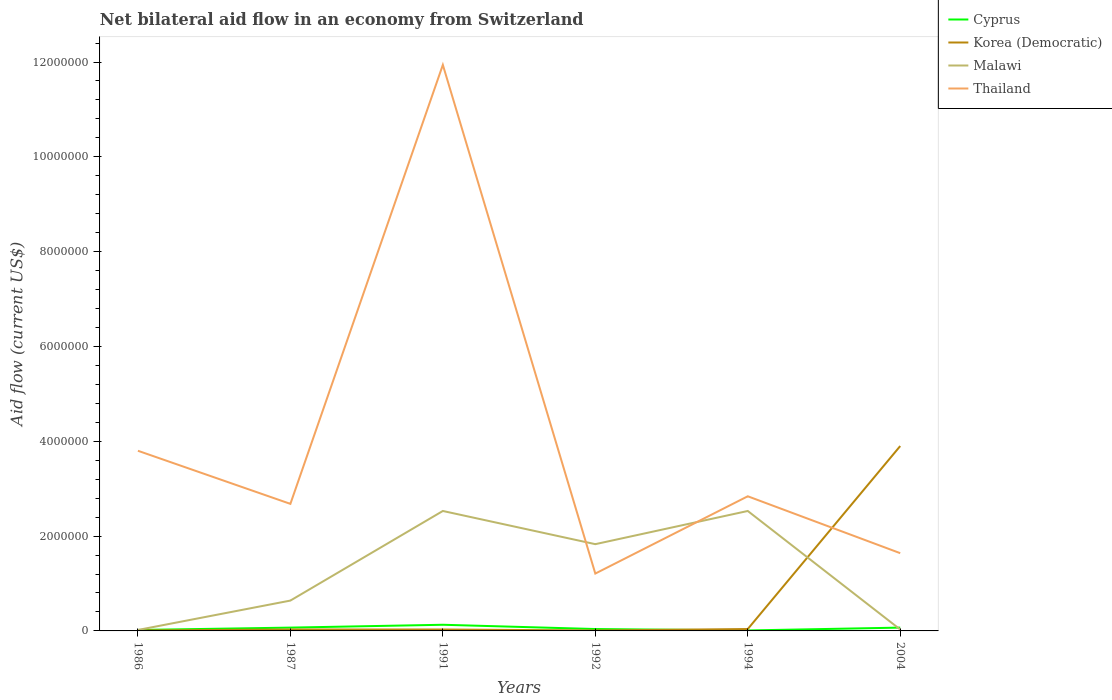How many different coloured lines are there?
Your answer should be compact. 4. Does the line corresponding to Korea (Democratic) intersect with the line corresponding to Malawi?
Your response must be concise. Yes. Is the number of lines equal to the number of legend labels?
Offer a terse response. Yes. What is the difference between the highest and the second highest net bilateral aid flow in Malawi?
Ensure brevity in your answer.  2.51e+06. What is the difference between two consecutive major ticks on the Y-axis?
Provide a short and direct response. 2.00e+06. Are the values on the major ticks of Y-axis written in scientific E-notation?
Make the answer very short. No. Does the graph contain grids?
Offer a terse response. No. How many legend labels are there?
Offer a terse response. 4. What is the title of the graph?
Keep it short and to the point. Net bilateral aid flow in an economy from Switzerland. Does "Pakistan" appear as one of the legend labels in the graph?
Your answer should be very brief. No. What is the label or title of the X-axis?
Give a very brief answer. Years. What is the label or title of the Y-axis?
Your answer should be compact. Aid flow (current US$). What is the Aid flow (current US$) in Thailand in 1986?
Your answer should be compact. 3.80e+06. What is the Aid flow (current US$) of Korea (Democratic) in 1987?
Give a very brief answer. 3.00e+04. What is the Aid flow (current US$) in Malawi in 1987?
Provide a short and direct response. 6.40e+05. What is the Aid flow (current US$) of Thailand in 1987?
Give a very brief answer. 2.68e+06. What is the Aid flow (current US$) in Malawi in 1991?
Ensure brevity in your answer.  2.53e+06. What is the Aid flow (current US$) of Thailand in 1991?
Offer a very short reply. 1.19e+07. What is the Aid flow (current US$) in Cyprus in 1992?
Give a very brief answer. 4.00e+04. What is the Aid flow (current US$) in Korea (Democratic) in 1992?
Offer a terse response. 10000. What is the Aid flow (current US$) of Malawi in 1992?
Keep it short and to the point. 1.83e+06. What is the Aid flow (current US$) of Thailand in 1992?
Provide a short and direct response. 1.21e+06. What is the Aid flow (current US$) in Korea (Democratic) in 1994?
Your answer should be compact. 4.00e+04. What is the Aid flow (current US$) in Malawi in 1994?
Your response must be concise. 2.53e+06. What is the Aid flow (current US$) in Thailand in 1994?
Your answer should be very brief. 2.84e+06. What is the Aid flow (current US$) of Cyprus in 2004?
Your answer should be compact. 7.00e+04. What is the Aid flow (current US$) of Korea (Democratic) in 2004?
Give a very brief answer. 3.90e+06. What is the Aid flow (current US$) of Thailand in 2004?
Offer a terse response. 1.64e+06. Across all years, what is the maximum Aid flow (current US$) of Korea (Democratic)?
Offer a very short reply. 3.90e+06. Across all years, what is the maximum Aid flow (current US$) in Malawi?
Give a very brief answer. 2.53e+06. Across all years, what is the maximum Aid flow (current US$) in Thailand?
Your response must be concise. 1.19e+07. Across all years, what is the minimum Aid flow (current US$) of Cyprus?
Your response must be concise. 10000. Across all years, what is the minimum Aid flow (current US$) of Korea (Democratic)?
Your response must be concise. 10000. Across all years, what is the minimum Aid flow (current US$) in Thailand?
Keep it short and to the point. 1.21e+06. What is the total Aid flow (current US$) in Cyprus in the graph?
Offer a terse response. 3.40e+05. What is the total Aid flow (current US$) of Korea (Democratic) in the graph?
Give a very brief answer. 4.02e+06. What is the total Aid flow (current US$) in Malawi in the graph?
Give a very brief answer. 7.58e+06. What is the total Aid flow (current US$) of Thailand in the graph?
Offer a terse response. 2.41e+07. What is the difference between the Aid flow (current US$) of Malawi in 1986 and that in 1987?
Ensure brevity in your answer.  -6.20e+05. What is the difference between the Aid flow (current US$) in Thailand in 1986 and that in 1987?
Give a very brief answer. 1.12e+06. What is the difference between the Aid flow (current US$) of Cyprus in 1986 and that in 1991?
Offer a terse response. -1.10e+05. What is the difference between the Aid flow (current US$) in Malawi in 1986 and that in 1991?
Offer a very short reply. -2.51e+06. What is the difference between the Aid flow (current US$) of Thailand in 1986 and that in 1991?
Keep it short and to the point. -8.14e+06. What is the difference between the Aid flow (current US$) in Korea (Democratic) in 1986 and that in 1992?
Your response must be concise. 0. What is the difference between the Aid flow (current US$) in Malawi in 1986 and that in 1992?
Ensure brevity in your answer.  -1.81e+06. What is the difference between the Aid flow (current US$) in Thailand in 1986 and that in 1992?
Your answer should be very brief. 2.59e+06. What is the difference between the Aid flow (current US$) of Cyprus in 1986 and that in 1994?
Your answer should be very brief. 10000. What is the difference between the Aid flow (current US$) of Korea (Democratic) in 1986 and that in 1994?
Keep it short and to the point. -3.00e+04. What is the difference between the Aid flow (current US$) in Malawi in 1986 and that in 1994?
Offer a very short reply. -2.51e+06. What is the difference between the Aid flow (current US$) of Thailand in 1986 and that in 1994?
Your response must be concise. 9.60e+05. What is the difference between the Aid flow (current US$) of Cyprus in 1986 and that in 2004?
Keep it short and to the point. -5.00e+04. What is the difference between the Aid flow (current US$) of Korea (Democratic) in 1986 and that in 2004?
Ensure brevity in your answer.  -3.89e+06. What is the difference between the Aid flow (current US$) in Thailand in 1986 and that in 2004?
Offer a terse response. 2.16e+06. What is the difference between the Aid flow (current US$) in Cyprus in 1987 and that in 1991?
Your response must be concise. -6.00e+04. What is the difference between the Aid flow (current US$) of Korea (Democratic) in 1987 and that in 1991?
Your answer should be very brief. 0. What is the difference between the Aid flow (current US$) of Malawi in 1987 and that in 1991?
Your response must be concise. -1.89e+06. What is the difference between the Aid flow (current US$) in Thailand in 1987 and that in 1991?
Give a very brief answer. -9.26e+06. What is the difference between the Aid flow (current US$) of Cyprus in 1987 and that in 1992?
Offer a terse response. 3.00e+04. What is the difference between the Aid flow (current US$) in Korea (Democratic) in 1987 and that in 1992?
Ensure brevity in your answer.  2.00e+04. What is the difference between the Aid flow (current US$) in Malawi in 1987 and that in 1992?
Offer a very short reply. -1.19e+06. What is the difference between the Aid flow (current US$) in Thailand in 1987 and that in 1992?
Offer a terse response. 1.47e+06. What is the difference between the Aid flow (current US$) in Cyprus in 1987 and that in 1994?
Give a very brief answer. 6.00e+04. What is the difference between the Aid flow (current US$) of Korea (Democratic) in 1987 and that in 1994?
Offer a very short reply. -10000. What is the difference between the Aid flow (current US$) of Malawi in 1987 and that in 1994?
Your response must be concise. -1.89e+06. What is the difference between the Aid flow (current US$) of Thailand in 1987 and that in 1994?
Keep it short and to the point. -1.60e+05. What is the difference between the Aid flow (current US$) of Korea (Democratic) in 1987 and that in 2004?
Provide a short and direct response. -3.87e+06. What is the difference between the Aid flow (current US$) of Thailand in 1987 and that in 2004?
Provide a succinct answer. 1.04e+06. What is the difference between the Aid flow (current US$) in Cyprus in 1991 and that in 1992?
Give a very brief answer. 9.00e+04. What is the difference between the Aid flow (current US$) in Korea (Democratic) in 1991 and that in 1992?
Your response must be concise. 2.00e+04. What is the difference between the Aid flow (current US$) of Thailand in 1991 and that in 1992?
Ensure brevity in your answer.  1.07e+07. What is the difference between the Aid flow (current US$) of Korea (Democratic) in 1991 and that in 1994?
Provide a succinct answer. -10000. What is the difference between the Aid flow (current US$) of Malawi in 1991 and that in 1994?
Make the answer very short. 0. What is the difference between the Aid flow (current US$) of Thailand in 1991 and that in 1994?
Offer a very short reply. 9.10e+06. What is the difference between the Aid flow (current US$) in Korea (Democratic) in 1991 and that in 2004?
Provide a succinct answer. -3.87e+06. What is the difference between the Aid flow (current US$) in Malawi in 1991 and that in 2004?
Provide a succinct answer. 2.50e+06. What is the difference between the Aid flow (current US$) of Thailand in 1991 and that in 2004?
Provide a short and direct response. 1.03e+07. What is the difference between the Aid flow (current US$) in Malawi in 1992 and that in 1994?
Your answer should be very brief. -7.00e+05. What is the difference between the Aid flow (current US$) of Thailand in 1992 and that in 1994?
Offer a terse response. -1.63e+06. What is the difference between the Aid flow (current US$) of Korea (Democratic) in 1992 and that in 2004?
Your answer should be very brief. -3.89e+06. What is the difference between the Aid flow (current US$) in Malawi in 1992 and that in 2004?
Make the answer very short. 1.80e+06. What is the difference between the Aid flow (current US$) of Thailand in 1992 and that in 2004?
Your answer should be very brief. -4.30e+05. What is the difference between the Aid flow (current US$) in Cyprus in 1994 and that in 2004?
Your answer should be very brief. -6.00e+04. What is the difference between the Aid flow (current US$) of Korea (Democratic) in 1994 and that in 2004?
Provide a short and direct response. -3.86e+06. What is the difference between the Aid flow (current US$) of Malawi in 1994 and that in 2004?
Ensure brevity in your answer.  2.50e+06. What is the difference between the Aid flow (current US$) of Thailand in 1994 and that in 2004?
Make the answer very short. 1.20e+06. What is the difference between the Aid flow (current US$) in Cyprus in 1986 and the Aid flow (current US$) in Malawi in 1987?
Offer a very short reply. -6.20e+05. What is the difference between the Aid flow (current US$) of Cyprus in 1986 and the Aid flow (current US$) of Thailand in 1987?
Offer a very short reply. -2.66e+06. What is the difference between the Aid flow (current US$) in Korea (Democratic) in 1986 and the Aid flow (current US$) in Malawi in 1987?
Offer a terse response. -6.30e+05. What is the difference between the Aid flow (current US$) of Korea (Democratic) in 1986 and the Aid flow (current US$) of Thailand in 1987?
Ensure brevity in your answer.  -2.67e+06. What is the difference between the Aid flow (current US$) of Malawi in 1986 and the Aid flow (current US$) of Thailand in 1987?
Offer a terse response. -2.66e+06. What is the difference between the Aid flow (current US$) in Cyprus in 1986 and the Aid flow (current US$) in Malawi in 1991?
Your answer should be compact. -2.51e+06. What is the difference between the Aid flow (current US$) in Cyprus in 1986 and the Aid flow (current US$) in Thailand in 1991?
Ensure brevity in your answer.  -1.19e+07. What is the difference between the Aid flow (current US$) of Korea (Democratic) in 1986 and the Aid flow (current US$) of Malawi in 1991?
Your answer should be very brief. -2.52e+06. What is the difference between the Aid flow (current US$) of Korea (Democratic) in 1986 and the Aid flow (current US$) of Thailand in 1991?
Keep it short and to the point. -1.19e+07. What is the difference between the Aid flow (current US$) in Malawi in 1986 and the Aid flow (current US$) in Thailand in 1991?
Give a very brief answer. -1.19e+07. What is the difference between the Aid flow (current US$) of Cyprus in 1986 and the Aid flow (current US$) of Korea (Democratic) in 1992?
Give a very brief answer. 10000. What is the difference between the Aid flow (current US$) of Cyprus in 1986 and the Aid flow (current US$) of Malawi in 1992?
Your response must be concise. -1.81e+06. What is the difference between the Aid flow (current US$) of Cyprus in 1986 and the Aid flow (current US$) of Thailand in 1992?
Your answer should be compact. -1.19e+06. What is the difference between the Aid flow (current US$) in Korea (Democratic) in 1986 and the Aid flow (current US$) in Malawi in 1992?
Offer a terse response. -1.82e+06. What is the difference between the Aid flow (current US$) in Korea (Democratic) in 1986 and the Aid flow (current US$) in Thailand in 1992?
Your response must be concise. -1.20e+06. What is the difference between the Aid flow (current US$) of Malawi in 1986 and the Aid flow (current US$) of Thailand in 1992?
Offer a terse response. -1.19e+06. What is the difference between the Aid flow (current US$) of Cyprus in 1986 and the Aid flow (current US$) of Malawi in 1994?
Keep it short and to the point. -2.51e+06. What is the difference between the Aid flow (current US$) of Cyprus in 1986 and the Aid flow (current US$) of Thailand in 1994?
Ensure brevity in your answer.  -2.82e+06. What is the difference between the Aid flow (current US$) in Korea (Democratic) in 1986 and the Aid flow (current US$) in Malawi in 1994?
Your response must be concise. -2.52e+06. What is the difference between the Aid flow (current US$) in Korea (Democratic) in 1986 and the Aid flow (current US$) in Thailand in 1994?
Keep it short and to the point. -2.83e+06. What is the difference between the Aid flow (current US$) in Malawi in 1986 and the Aid flow (current US$) in Thailand in 1994?
Keep it short and to the point. -2.82e+06. What is the difference between the Aid flow (current US$) in Cyprus in 1986 and the Aid flow (current US$) in Korea (Democratic) in 2004?
Give a very brief answer. -3.88e+06. What is the difference between the Aid flow (current US$) of Cyprus in 1986 and the Aid flow (current US$) of Malawi in 2004?
Make the answer very short. -10000. What is the difference between the Aid flow (current US$) in Cyprus in 1986 and the Aid flow (current US$) in Thailand in 2004?
Ensure brevity in your answer.  -1.62e+06. What is the difference between the Aid flow (current US$) in Korea (Democratic) in 1986 and the Aid flow (current US$) in Malawi in 2004?
Provide a succinct answer. -2.00e+04. What is the difference between the Aid flow (current US$) in Korea (Democratic) in 1986 and the Aid flow (current US$) in Thailand in 2004?
Your response must be concise. -1.63e+06. What is the difference between the Aid flow (current US$) of Malawi in 1986 and the Aid flow (current US$) of Thailand in 2004?
Offer a terse response. -1.62e+06. What is the difference between the Aid flow (current US$) of Cyprus in 1987 and the Aid flow (current US$) of Korea (Democratic) in 1991?
Offer a very short reply. 4.00e+04. What is the difference between the Aid flow (current US$) in Cyprus in 1987 and the Aid flow (current US$) in Malawi in 1991?
Provide a short and direct response. -2.46e+06. What is the difference between the Aid flow (current US$) of Cyprus in 1987 and the Aid flow (current US$) of Thailand in 1991?
Provide a short and direct response. -1.19e+07. What is the difference between the Aid flow (current US$) in Korea (Democratic) in 1987 and the Aid flow (current US$) in Malawi in 1991?
Keep it short and to the point. -2.50e+06. What is the difference between the Aid flow (current US$) of Korea (Democratic) in 1987 and the Aid flow (current US$) of Thailand in 1991?
Keep it short and to the point. -1.19e+07. What is the difference between the Aid flow (current US$) in Malawi in 1987 and the Aid flow (current US$) in Thailand in 1991?
Keep it short and to the point. -1.13e+07. What is the difference between the Aid flow (current US$) of Cyprus in 1987 and the Aid flow (current US$) of Korea (Democratic) in 1992?
Your response must be concise. 6.00e+04. What is the difference between the Aid flow (current US$) of Cyprus in 1987 and the Aid flow (current US$) of Malawi in 1992?
Your answer should be compact. -1.76e+06. What is the difference between the Aid flow (current US$) of Cyprus in 1987 and the Aid flow (current US$) of Thailand in 1992?
Provide a short and direct response. -1.14e+06. What is the difference between the Aid flow (current US$) in Korea (Democratic) in 1987 and the Aid flow (current US$) in Malawi in 1992?
Your answer should be compact. -1.80e+06. What is the difference between the Aid flow (current US$) of Korea (Democratic) in 1987 and the Aid flow (current US$) of Thailand in 1992?
Make the answer very short. -1.18e+06. What is the difference between the Aid flow (current US$) of Malawi in 1987 and the Aid flow (current US$) of Thailand in 1992?
Offer a terse response. -5.70e+05. What is the difference between the Aid flow (current US$) of Cyprus in 1987 and the Aid flow (current US$) of Malawi in 1994?
Give a very brief answer. -2.46e+06. What is the difference between the Aid flow (current US$) in Cyprus in 1987 and the Aid flow (current US$) in Thailand in 1994?
Provide a succinct answer. -2.77e+06. What is the difference between the Aid flow (current US$) of Korea (Democratic) in 1987 and the Aid flow (current US$) of Malawi in 1994?
Give a very brief answer. -2.50e+06. What is the difference between the Aid flow (current US$) of Korea (Democratic) in 1987 and the Aid flow (current US$) of Thailand in 1994?
Provide a succinct answer. -2.81e+06. What is the difference between the Aid flow (current US$) in Malawi in 1987 and the Aid flow (current US$) in Thailand in 1994?
Your answer should be very brief. -2.20e+06. What is the difference between the Aid flow (current US$) in Cyprus in 1987 and the Aid flow (current US$) in Korea (Democratic) in 2004?
Your answer should be very brief. -3.83e+06. What is the difference between the Aid flow (current US$) of Cyprus in 1987 and the Aid flow (current US$) of Thailand in 2004?
Your response must be concise. -1.57e+06. What is the difference between the Aid flow (current US$) in Korea (Democratic) in 1987 and the Aid flow (current US$) in Thailand in 2004?
Provide a short and direct response. -1.61e+06. What is the difference between the Aid flow (current US$) in Malawi in 1987 and the Aid flow (current US$) in Thailand in 2004?
Give a very brief answer. -1.00e+06. What is the difference between the Aid flow (current US$) of Cyprus in 1991 and the Aid flow (current US$) of Korea (Democratic) in 1992?
Keep it short and to the point. 1.20e+05. What is the difference between the Aid flow (current US$) in Cyprus in 1991 and the Aid flow (current US$) in Malawi in 1992?
Your answer should be compact. -1.70e+06. What is the difference between the Aid flow (current US$) of Cyprus in 1991 and the Aid flow (current US$) of Thailand in 1992?
Offer a terse response. -1.08e+06. What is the difference between the Aid flow (current US$) in Korea (Democratic) in 1991 and the Aid flow (current US$) in Malawi in 1992?
Make the answer very short. -1.80e+06. What is the difference between the Aid flow (current US$) in Korea (Democratic) in 1991 and the Aid flow (current US$) in Thailand in 1992?
Your response must be concise. -1.18e+06. What is the difference between the Aid flow (current US$) in Malawi in 1991 and the Aid flow (current US$) in Thailand in 1992?
Make the answer very short. 1.32e+06. What is the difference between the Aid flow (current US$) of Cyprus in 1991 and the Aid flow (current US$) of Malawi in 1994?
Provide a succinct answer. -2.40e+06. What is the difference between the Aid flow (current US$) in Cyprus in 1991 and the Aid flow (current US$) in Thailand in 1994?
Provide a succinct answer. -2.71e+06. What is the difference between the Aid flow (current US$) of Korea (Democratic) in 1991 and the Aid flow (current US$) of Malawi in 1994?
Offer a terse response. -2.50e+06. What is the difference between the Aid flow (current US$) of Korea (Democratic) in 1991 and the Aid flow (current US$) of Thailand in 1994?
Offer a terse response. -2.81e+06. What is the difference between the Aid flow (current US$) of Malawi in 1991 and the Aid flow (current US$) of Thailand in 1994?
Provide a succinct answer. -3.10e+05. What is the difference between the Aid flow (current US$) in Cyprus in 1991 and the Aid flow (current US$) in Korea (Democratic) in 2004?
Make the answer very short. -3.77e+06. What is the difference between the Aid flow (current US$) of Cyprus in 1991 and the Aid flow (current US$) of Thailand in 2004?
Your response must be concise. -1.51e+06. What is the difference between the Aid flow (current US$) of Korea (Democratic) in 1991 and the Aid flow (current US$) of Thailand in 2004?
Offer a terse response. -1.61e+06. What is the difference between the Aid flow (current US$) in Malawi in 1991 and the Aid flow (current US$) in Thailand in 2004?
Provide a succinct answer. 8.90e+05. What is the difference between the Aid flow (current US$) of Cyprus in 1992 and the Aid flow (current US$) of Korea (Democratic) in 1994?
Provide a short and direct response. 0. What is the difference between the Aid flow (current US$) of Cyprus in 1992 and the Aid flow (current US$) of Malawi in 1994?
Offer a very short reply. -2.49e+06. What is the difference between the Aid flow (current US$) in Cyprus in 1992 and the Aid flow (current US$) in Thailand in 1994?
Offer a very short reply. -2.80e+06. What is the difference between the Aid flow (current US$) of Korea (Democratic) in 1992 and the Aid flow (current US$) of Malawi in 1994?
Ensure brevity in your answer.  -2.52e+06. What is the difference between the Aid flow (current US$) in Korea (Democratic) in 1992 and the Aid flow (current US$) in Thailand in 1994?
Give a very brief answer. -2.83e+06. What is the difference between the Aid flow (current US$) of Malawi in 1992 and the Aid flow (current US$) of Thailand in 1994?
Offer a terse response. -1.01e+06. What is the difference between the Aid flow (current US$) in Cyprus in 1992 and the Aid flow (current US$) in Korea (Democratic) in 2004?
Keep it short and to the point. -3.86e+06. What is the difference between the Aid flow (current US$) in Cyprus in 1992 and the Aid flow (current US$) in Thailand in 2004?
Offer a very short reply. -1.60e+06. What is the difference between the Aid flow (current US$) of Korea (Democratic) in 1992 and the Aid flow (current US$) of Thailand in 2004?
Give a very brief answer. -1.63e+06. What is the difference between the Aid flow (current US$) in Malawi in 1992 and the Aid flow (current US$) in Thailand in 2004?
Offer a very short reply. 1.90e+05. What is the difference between the Aid flow (current US$) in Cyprus in 1994 and the Aid flow (current US$) in Korea (Democratic) in 2004?
Make the answer very short. -3.89e+06. What is the difference between the Aid flow (current US$) of Cyprus in 1994 and the Aid flow (current US$) of Malawi in 2004?
Ensure brevity in your answer.  -2.00e+04. What is the difference between the Aid flow (current US$) of Cyprus in 1994 and the Aid flow (current US$) of Thailand in 2004?
Your answer should be compact. -1.63e+06. What is the difference between the Aid flow (current US$) in Korea (Democratic) in 1994 and the Aid flow (current US$) in Thailand in 2004?
Provide a short and direct response. -1.60e+06. What is the difference between the Aid flow (current US$) in Malawi in 1994 and the Aid flow (current US$) in Thailand in 2004?
Give a very brief answer. 8.90e+05. What is the average Aid flow (current US$) of Cyprus per year?
Provide a short and direct response. 5.67e+04. What is the average Aid flow (current US$) of Korea (Democratic) per year?
Your response must be concise. 6.70e+05. What is the average Aid flow (current US$) of Malawi per year?
Your answer should be compact. 1.26e+06. What is the average Aid flow (current US$) in Thailand per year?
Provide a short and direct response. 4.02e+06. In the year 1986, what is the difference between the Aid flow (current US$) of Cyprus and Aid flow (current US$) of Malawi?
Make the answer very short. 0. In the year 1986, what is the difference between the Aid flow (current US$) of Cyprus and Aid flow (current US$) of Thailand?
Make the answer very short. -3.78e+06. In the year 1986, what is the difference between the Aid flow (current US$) of Korea (Democratic) and Aid flow (current US$) of Thailand?
Offer a terse response. -3.79e+06. In the year 1986, what is the difference between the Aid flow (current US$) in Malawi and Aid flow (current US$) in Thailand?
Your answer should be very brief. -3.78e+06. In the year 1987, what is the difference between the Aid flow (current US$) in Cyprus and Aid flow (current US$) in Korea (Democratic)?
Give a very brief answer. 4.00e+04. In the year 1987, what is the difference between the Aid flow (current US$) in Cyprus and Aid flow (current US$) in Malawi?
Give a very brief answer. -5.70e+05. In the year 1987, what is the difference between the Aid flow (current US$) in Cyprus and Aid flow (current US$) in Thailand?
Offer a very short reply. -2.61e+06. In the year 1987, what is the difference between the Aid flow (current US$) in Korea (Democratic) and Aid flow (current US$) in Malawi?
Provide a succinct answer. -6.10e+05. In the year 1987, what is the difference between the Aid flow (current US$) in Korea (Democratic) and Aid flow (current US$) in Thailand?
Provide a succinct answer. -2.65e+06. In the year 1987, what is the difference between the Aid flow (current US$) of Malawi and Aid flow (current US$) of Thailand?
Your answer should be compact. -2.04e+06. In the year 1991, what is the difference between the Aid flow (current US$) of Cyprus and Aid flow (current US$) of Korea (Democratic)?
Provide a succinct answer. 1.00e+05. In the year 1991, what is the difference between the Aid flow (current US$) in Cyprus and Aid flow (current US$) in Malawi?
Keep it short and to the point. -2.40e+06. In the year 1991, what is the difference between the Aid flow (current US$) of Cyprus and Aid flow (current US$) of Thailand?
Offer a terse response. -1.18e+07. In the year 1991, what is the difference between the Aid flow (current US$) in Korea (Democratic) and Aid flow (current US$) in Malawi?
Give a very brief answer. -2.50e+06. In the year 1991, what is the difference between the Aid flow (current US$) of Korea (Democratic) and Aid flow (current US$) of Thailand?
Give a very brief answer. -1.19e+07. In the year 1991, what is the difference between the Aid flow (current US$) of Malawi and Aid flow (current US$) of Thailand?
Give a very brief answer. -9.41e+06. In the year 1992, what is the difference between the Aid flow (current US$) in Cyprus and Aid flow (current US$) in Korea (Democratic)?
Offer a very short reply. 3.00e+04. In the year 1992, what is the difference between the Aid flow (current US$) of Cyprus and Aid flow (current US$) of Malawi?
Provide a succinct answer. -1.79e+06. In the year 1992, what is the difference between the Aid flow (current US$) in Cyprus and Aid flow (current US$) in Thailand?
Give a very brief answer. -1.17e+06. In the year 1992, what is the difference between the Aid flow (current US$) in Korea (Democratic) and Aid flow (current US$) in Malawi?
Keep it short and to the point. -1.82e+06. In the year 1992, what is the difference between the Aid flow (current US$) in Korea (Democratic) and Aid flow (current US$) in Thailand?
Give a very brief answer. -1.20e+06. In the year 1992, what is the difference between the Aid flow (current US$) of Malawi and Aid flow (current US$) of Thailand?
Keep it short and to the point. 6.20e+05. In the year 1994, what is the difference between the Aid flow (current US$) in Cyprus and Aid flow (current US$) in Malawi?
Your response must be concise. -2.52e+06. In the year 1994, what is the difference between the Aid flow (current US$) in Cyprus and Aid flow (current US$) in Thailand?
Your response must be concise. -2.83e+06. In the year 1994, what is the difference between the Aid flow (current US$) in Korea (Democratic) and Aid flow (current US$) in Malawi?
Your answer should be compact. -2.49e+06. In the year 1994, what is the difference between the Aid flow (current US$) in Korea (Democratic) and Aid flow (current US$) in Thailand?
Keep it short and to the point. -2.80e+06. In the year 1994, what is the difference between the Aid flow (current US$) in Malawi and Aid flow (current US$) in Thailand?
Ensure brevity in your answer.  -3.10e+05. In the year 2004, what is the difference between the Aid flow (current US$) of Cyprus and Aid flow (current US$) of Korea (Democratic)?
Give a very brief answer. -3.83e+06. In the year 2004, what is the difference between the Aid flow (current US$) of Cyprus and Aid flow (current US$) of Malawi?
Your answer should be very brief. 4.00e+04. In the year 2004, what is the difference between the Aid flow (current US$) in Cyprus and Aid flow (current US$) in Thailand?
Provide a succinct answer. -1.57e+06. In the year 2004, what is the difference between the Aid flow (current US$) in Korea (Democratic) and Aid flow (current US$) in Malawi?
Offer a terse response. 3.87e+06. In the year 2004, what is the difference between the Aid flow (current US$) in Korea (Democratic) and Aid flow (current US$) in Thailand?
Provide a succinct answer. 2.26e+06. In the year 2004, what is the difference between the Aid flow (current US$) of Malawi and Aid flow (current US$) of Thailand?
Offer a very short reply. -1.61e+06. What is the ratio of the Aid flow (current US$) of Cyprus in 1986 to that in 1987?
Provide a succinct answer. 0.29. What is the ratio of the Aid flow (current US$) of Malawi in 1986 to that in 1987?
Your answer should be compact. 0.03. What is the ratio of the Aid flow (current US$) of Thailand in 1986 to that in 1987?
Ensure brevity in your answer.  1.42. What is the ratio of the Aid flow (current US$) of Cyprus in 1986 to that in 1991?
Provide a short and direct response. 0.15. What is the ratio of the Aid flow (current US$) of Korea (Democratic) in 1986 to that in 1991?
Provide a succinct answer. 0.33. What is the ratio of the Aid flow (current US$) of Malawi in 1986 to that in 1991?
Keep it short and to the point. 0.01. What is the ratio of the Aid flow (current US$) in Thailand in 1986 to that in 1991?
Offer a very short reply. 0.32. What is the ratio of the Aid flow (current US$) in Korea (Democratic) in 1986 to that in 1992?
Give a very brief answer. 1. What is the ratio of the Aid flow (current US$) of Malawi in 1986 to that in 1992?
Keep it short and to the point. 0.01. What is the ratio of the Aid flow (current US$) in Thailand in 1986 to that in 1992?
Offer a very short reply. 3.14. What is the ratio of the Aid flow (current US$) in Cyprus in 1986 to that in 1994?
Offer a very short reply. 2. What is the ratio of the Aid flow (current US$) in Malawi in 1986 to that in 1994?
Ensure brevity in your answer.  0.01. What is the ratio of the Aid flow (current US$) in Thailand in 1986 to that in 1994?
Your response must be concise. 1.34. What is the ratio of the Aid flow (current US$) of Cyprus in 1986 to that in 2004?
Provide a short and direct response. 0.29. What is the ratio of the Aid flow (current US$) in Korea (Democratic) in 1986 to that in 2004?
Keep it short and to the point. 0. What is the ratio of the Aid flow (current US$) of Thailand in 1986 to that in 2004?
Your answer should be very brief. 2.32. What is the ratio of the Aid flow (current US$) of Cyprus in 1987 to that in 1991?
Your answer should be compact. 0.54. What is the ratio of the Aid flow (current US$) in Korea (Democratic) in 1987 to that in 1991?
Your response must be concise. 1. What is the ratio of the Aid flow (current US$) of Malawi in 1987 to that in 1991?
Give a very brief answer. 0.25. What is the ratio of the Aid flow (current US$) in Thailand in 1987 to that in 1991?
Your response must be concise. 0.22. What is the ratio of the Aid flow (current US$) of Cyprus in 1987 to that in 1992?
Provide a short and direct response. 1.75. What is the ratio of the Aid flow (current US$) in Korea (Democratic) in 1987 to that in 1992?
Offer a terse response. 3. What is the ratio of the Aid flow (current US$) of Malawi in 1987 to that in 1992?
Your response must be concise. 0.35. What is the ratio of the Aid flow (current US$) of Thailand in 1987 to that in 1992?
Keep it short and to the point. 2.21. What is the ratio of the Aid flow (current US$) in Cyprus in 1987 to that in 1994?
Give a very brief answer. 7. What is the ratio of the Aid flow (current US$) of Korea (Democratic) in 1987 to that in 1994?
Offer a very short reply. 0.75. What is the ratio of the Aid flow (current US$) of Malawi in 1987 to that in 1994?
Provide a short and direct response. 0.25. What is the ratio of the Aid flow (current US$) of Thailand in 1987 to that in 1994?
Offer a very short reply. 0.94. What is the ratio of the Aid flow (current US$) in Cyprus in 1987 to that in 2004?
Provide a succinct answer. 1. What is the ratio of the Aid flow (current US$) of Korea (Democratic) in 1987 to that in 2004?
Give a very brief answer. 0.01. What is the ratio of the Aid flow (current US$) of Malawi in 1987 to that in 2004?
Offer a terse response. 21.33. What is the ratio of the Aid flow (current US$) of Thailand in 1987 to that in 2004?
Your response must be concise. 1.63. What is the ratio of the Aid flow (current US$) in Cyprus in 1991 to that in 1992?
Ensure brevity in your answer.  3.25. What is the ratio of the Aid flow (current US$) in Korea (Democratic) in 1991 to that in 1992?
Ensure brevity in your answer.  3. What is the ratio of the Aid flow (current US$) in Malawi in 1991 to that in 1992?
Offer a very short reply. 1.38. What is the ratio of the Aid flow (current US$) in Thailand in 1991 to that in 1992?
Ensure brevity in your answer.  9.87. What is the ratio of the Aid flow (current US$) of Malawi in 1991 to that in 1994?
Provide a short and direct response. 1. What is the ratio of the Aid flow (current US$) of Thailand in 1991 to that in 1994?
Offer a very short reply. 4.2. What is the ratio of the Aid flow (current US$) in Cyprus in 1991 to that in 2004?
Give a very brief answer. 1.86. What is the ratio of the Aid flow (current US$) in Korea (Democratic) in 1991 to that in 2004?
Give a very brief answer. 0.01. What is the ratio of the Aid flow (current US$) of Malawi in 1991 to that in 2004?
Provide a succinct answer. 84.33. What is the ratio of the Aid flow (current US$) in Thailand in 1991 to that in 2004?
Provide a succinct answer. 7.28. What is the ratio of the Aid flow (current US$) in Cyprus in 1992 to that in 1994?
Provide a succinct answer. 4. What is the ratio of the Aid flow (current US$) of Korea (Democratic) in 1992 to that in 1994?
Offer a terse response. 0.25. What is the ratio of the Aid flow (current US$) of Malawi in 1992 to that in 1994?
Give a very brief answer. 0.72. What is the ratio of the Aid flow (current US$) in Thailand in 1992 to that in 1994?
Provide a succinct answer. 0.43. What is the ratio of the Aid flow (current US$) of Korea (Democratic) in 1992 to that in 2004?
Give a very brief answer. 0. What is the ratio of the Aid flow (current US$) in Malawi in 1992 to that in 2004?
Offer a very short reply. 61. What is the ratio of the Aid flow (current US$) in Thailand in 1992 to that in 2004?
Ensure brevity in your answer.  0.74. What is the ratio of the Aid flow (current US$) in Cyprus in 1994 to that in 2004?
Provide a short and direct response. 0.14. What is the ratio of the Aid flow (current US$) in Korea (Democratic) in 1994 to that in 2004?
Offer a very short reply. 0.01. What is the ratio of the Aid flow (current US$) in Malawi in 1994 to that in 2004?
Offer a very short reply. 84.33. What is the ratio of the Aid flow (current US$) of Thailand in 1994 to that in 2004?
Offer a terse response. 1.73. What is the difference between the highest and the second highest Aid flow (current US$) in Korea (Democratic)?
Your response must be concise. 3.86e+06. What is the difference between the highest and the second highest Aid flow (current US$) of Malawi?
Provide a succinct answer. 0. What is the difference between the highest and the second highest Aid flow (current US$) of Thailand?
Ensure brevity in your answer.  8.14e+06. What is the difference between the highest and the lowest Aid flow (current US$) of Korea (Democratic)?
Keep it short and to the point. 3.89e+06. What is the difference between the highest and the lowest Aid flow (current US$) of Malawi?
Offer a terse response. 2.51e+06. What is the difference between the highest and the lowest Aid flow (current US$) in Thailand?
Offer a terse response. 1.07e+07. 